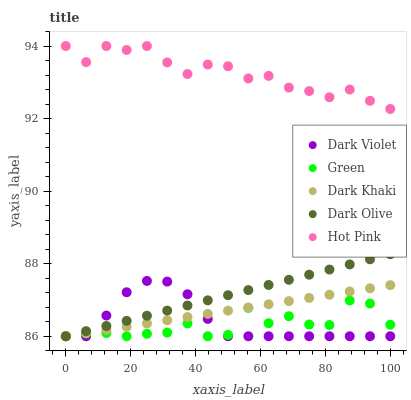Does Green have the minimum area under the curve?
Answer yes or no. Yes. Does Hot Pink have the maximum area under the curve?
Answer yes or no. Yes. Does Dark Olive have the minimum area under the curve?
Answer yes or no. No. Does Dark Olive have the maximum area under the curve?
Answer yes or no. No. Is Dark Khaki the smoothest?
Answer yes or no. Yes. Is Green the roughest?
Answer yes or no. Yes. Is Dark Olive the smoothest?
Answer yes or no. No. Is Dark Olive the roughest?
Answer yes or no. No. Does Dark Khaki have the lowest value?
Answer yes or no. Yes. Does Hot Pink have the lowest value?
Answer yes or no. No. Does Hot Pink have the highest value?
Answer yes or no. Yes. Does Dark Olive have the highest value?
Answer yes or no. No. Is Green less than Hot Pink?
Answer yes or no. Yes. Is Hot Pink greater than Green?
Answer yes or no. Yes. Does Dark Olive intersect Green?
Answer yes or no. Yes. Is Dark Olive less than Green?
Answer yes or no. No. Is Dark Olive greater than Green?
Answer yes or no. No. Does Green intersect Hot Pink?
Answer yes or no. No. 